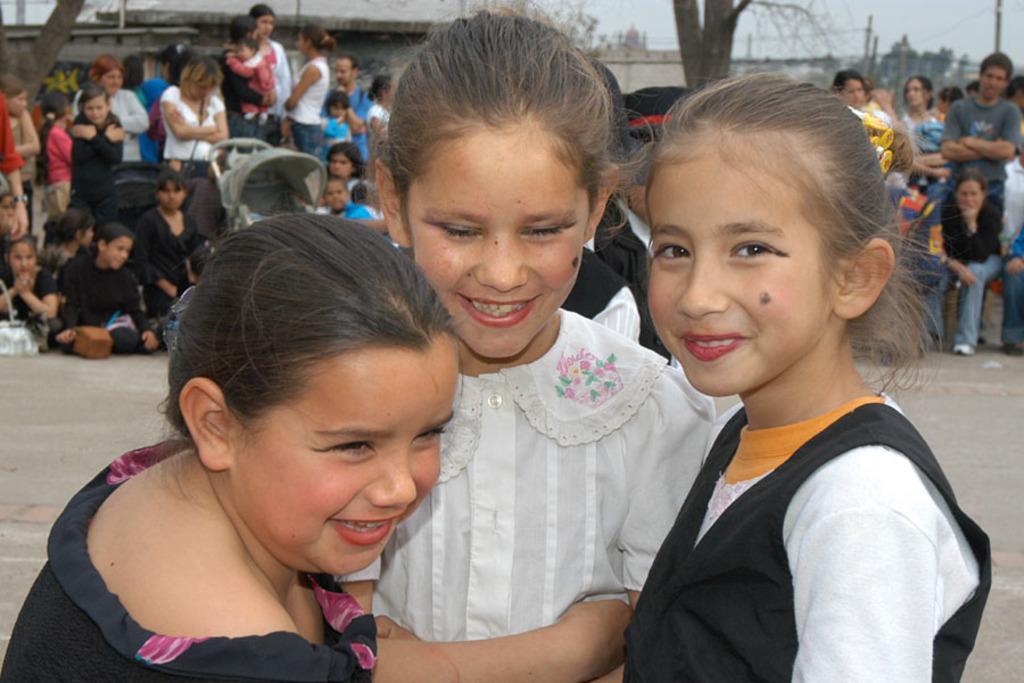In one or two sentences, can you explain what this image depicts? In the foreground of the image there are three kids. In the background of the image there are people. There are trees, wall. 